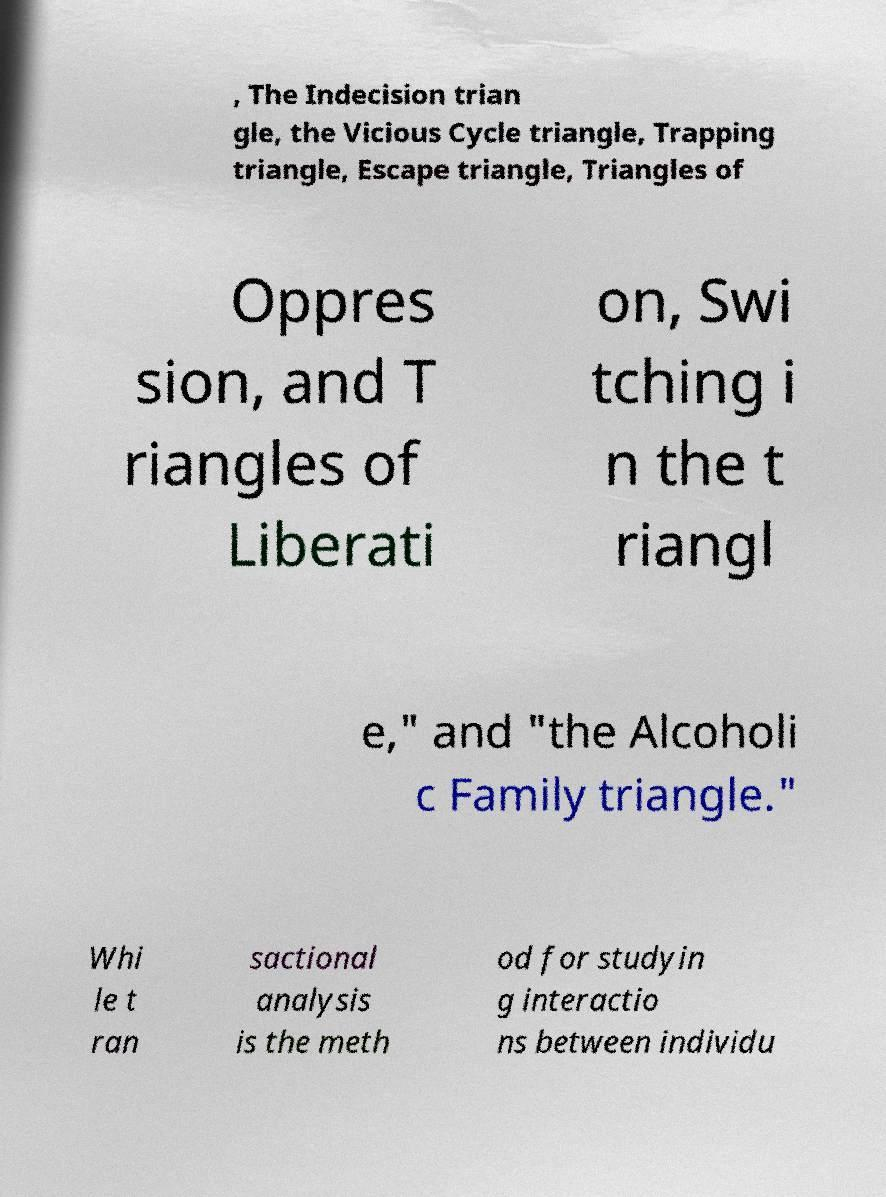I need the written content from this picture converted into text. Can you do that? , The Indecision trian gle, the Vicious Cycle triangle, Trapping triangle, Escape triangle, Triangles of Oppres sion, and T riangles of Liberati on, Swi tching i n the t riangl e," and "the Alcoholi c Family triangle." Whi le t ran sactional analysis is the meth od for studyin g interactio ns between individu 